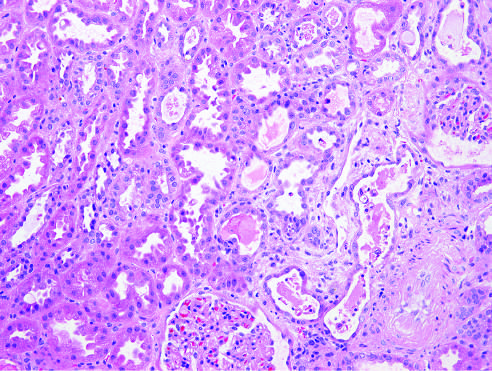does homogeneous or diffuse staining of nuclei cast?
Answer the question using a single word or phrase. No 